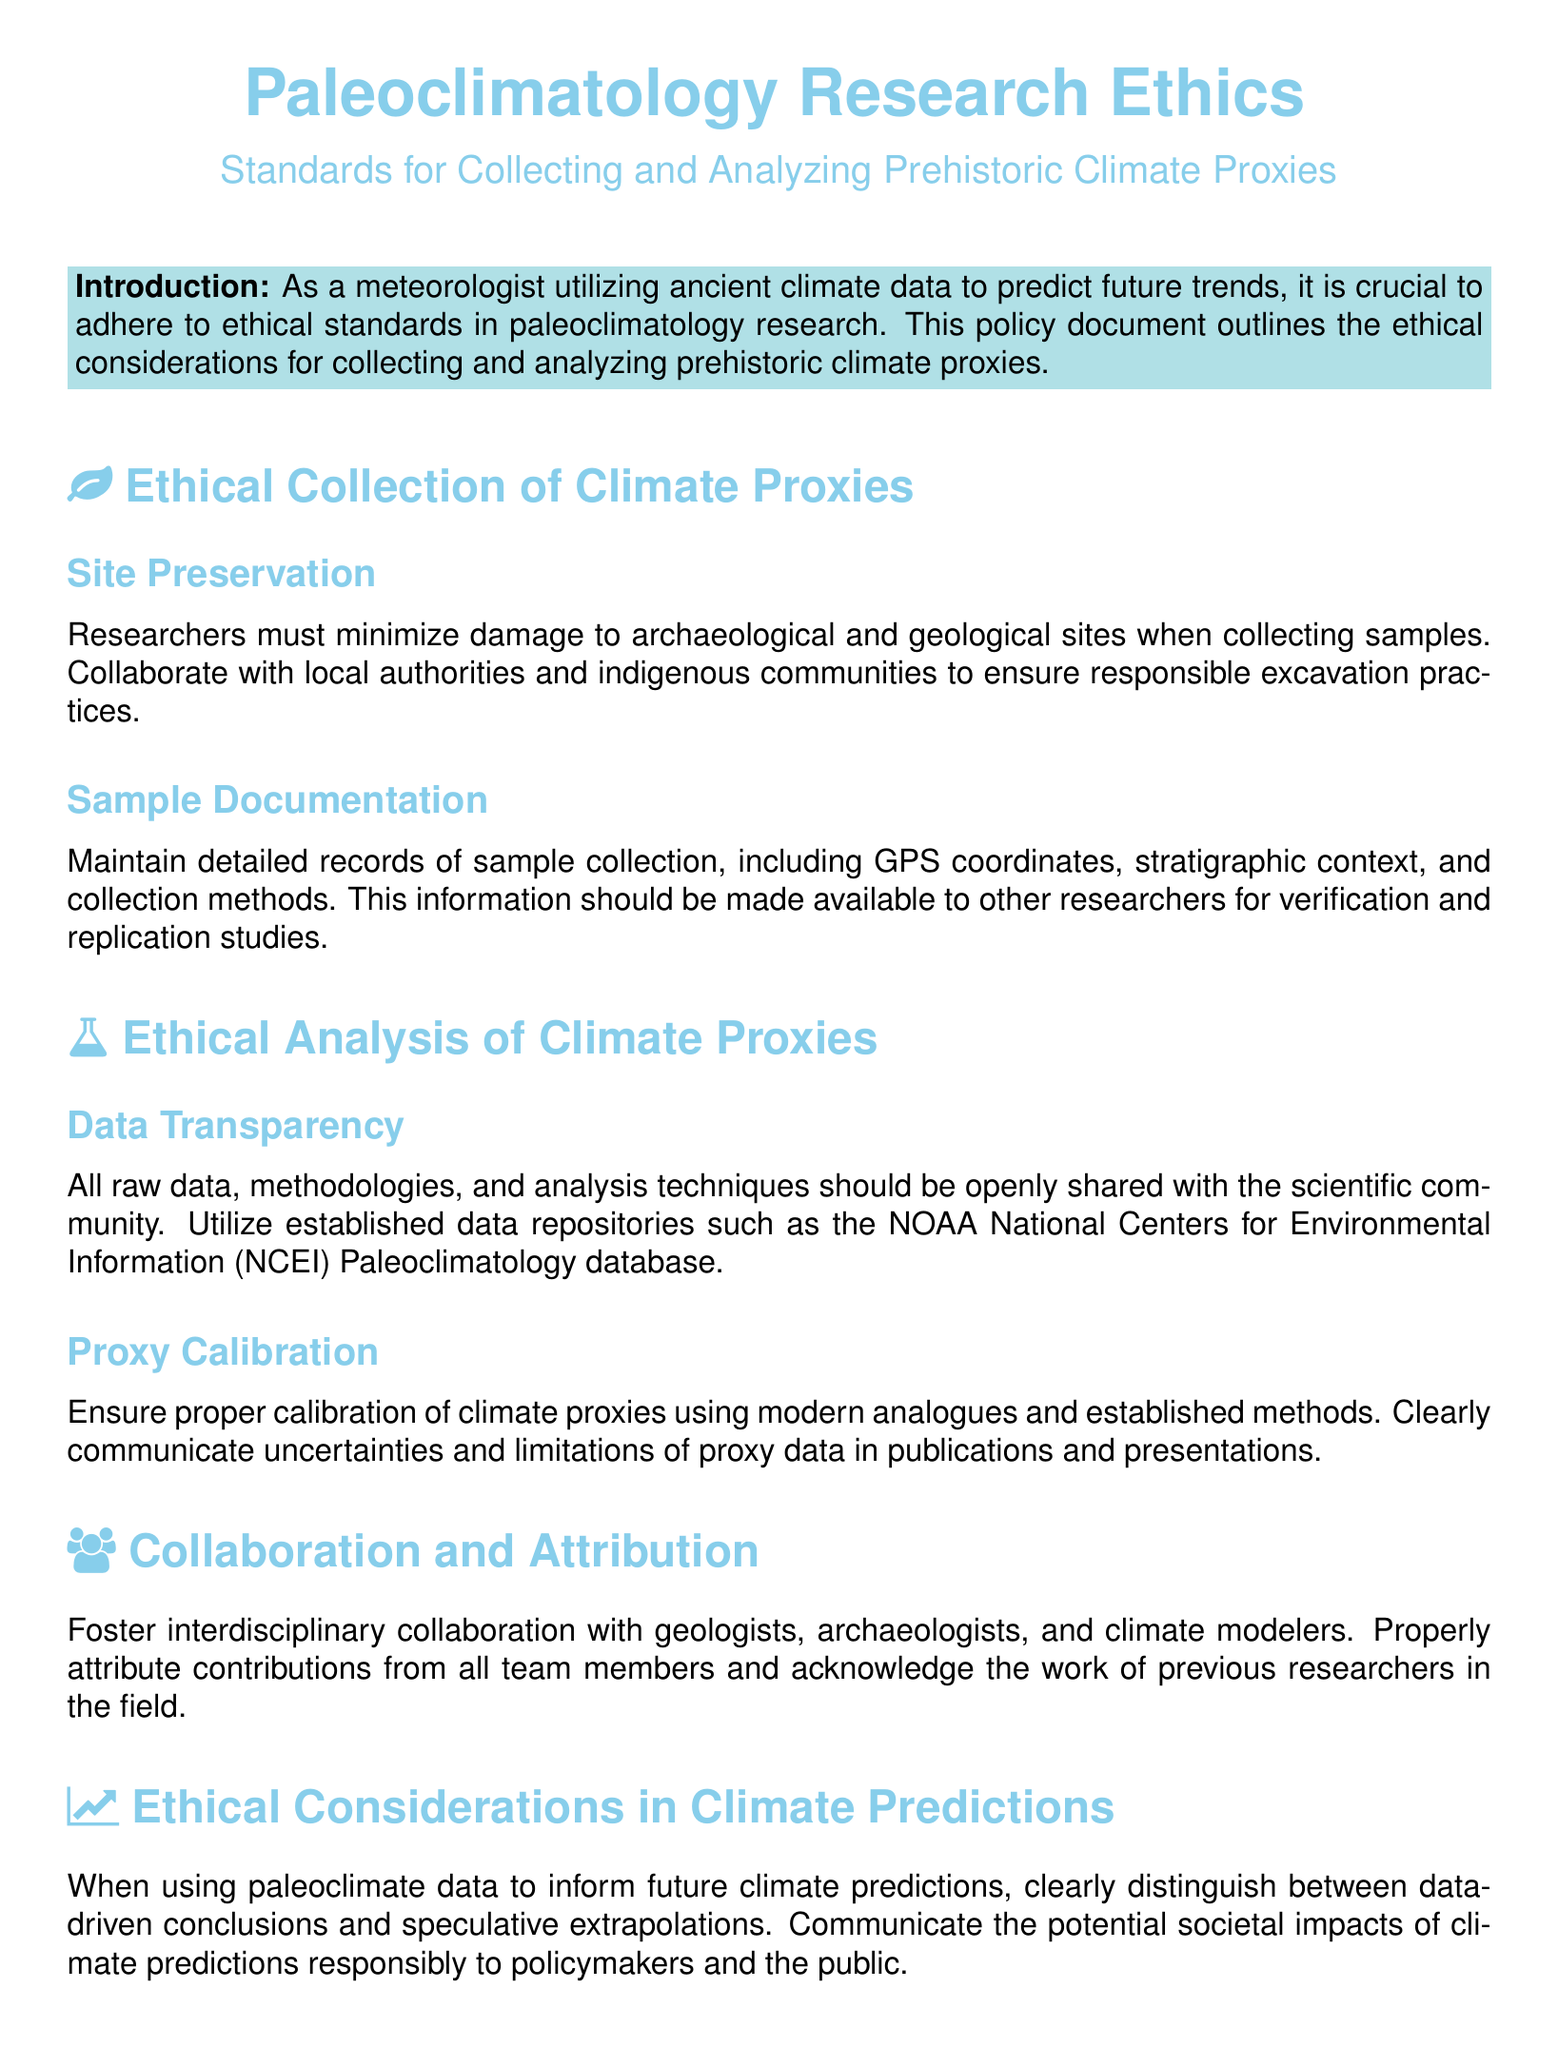What are the ethical standards for collecting climate proxies? The document outlines ethical standards such as site preservation, sample documentation, data transparency, proxy calibration, collaboration, attribution, and ethical considerations in climate predictions.
Answer: ethical standards for collecting climate proxies Who should researchers collaborate with during sample collection? The document states researchers must collaborate with local authorities and indigenous communities to ensure responsible excavation practices.
Answer: local authorities and indigenous communities What is required for sample documentation? Researchers must maintain detailed records including GPS coordinates, stratigraphic context, and collection methods for sample documentation.
Answer: GPS coordinates, stratigraphic context, and collection methods What is emphasized about data transparency? The document emphasizes that all raw data, methodologies, and analysis techniques should be openly shared with the scientific community.
Answer: openly shared with the scientific community What should researchers ensure about climate proxy calibration? Researchers should ensure proper calibration of climate proxies using modern analogues and established methods as indicated in the document.
Answer: proper calibration with modern analogues What is the purpose of interdisciplinary collaboration mentioned in the document? The document states the purpose is to foster collaboration with geologists, archaeologists, and climate modelers.
Answer: foster collaboration What distinguishes data-driven conclusions from speculative extrapolations? The document mentions that researchers should clearly distinguish between data-driven conclusions and speculative extrapolations when using paleoclimate data for future predictions.
Answer: data-driven conclusions and speculative extrapolations What type of document is this? The document is a policy document about ethical standards in paleoclimatology research.
Answer: policy document 